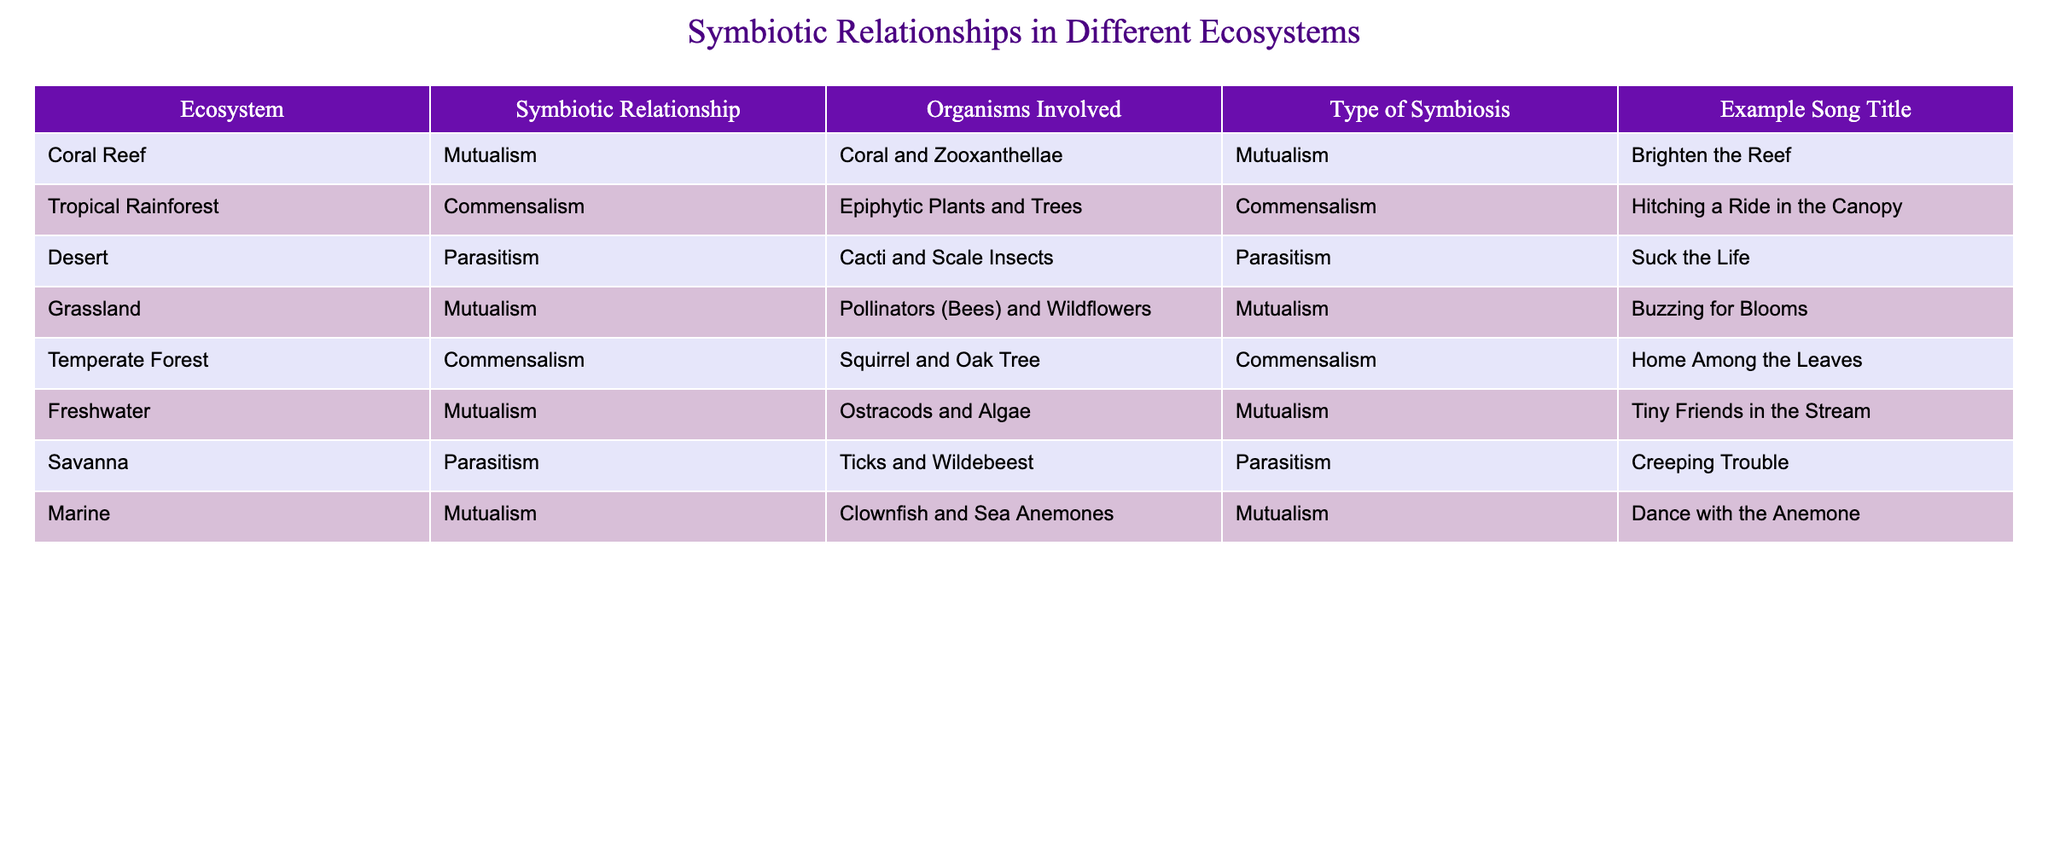What symbiotic relationship do coral and zooxanthellae exhibit? The table indicates that coral and zooxanthellae engage in mutualism, as listed in the corresponding row for the Coral Reef ecosystem.
Answer: Mutualism Which type of symbiosis is represented by the cacti and scale insects? The table clearly shows that the relationship between cacti and scale insects is classified as parasitism, as seen in the Desert ecosystem row.
Answer: Parasitism How many symbiotic relationships are classified as mutualism in the table? By examining the table, I can count three rows that indicate mutualism, specifically Coral and Zooxanthellae, Pollinators and Wildflowers, and Clownfish and Sea Anemones.
Answer: Three Is the relationship between ticks and wildebeest mutualism? The table states that the relationship between ticks and wildebeest is classified as parasitism, so the relationship is not mutualism.
Answer: No Which ecosystem features a commensal relationship involving a squirrel? Looking at the table, I can see that the Temperate Forest ecosystem features a commensal relationship involving a squirrel and an oak tree.
Answer: Temperate Forest If someone were to create a song about ostracods and algae, what title would they use according to the table? The table indicates that the song title for the mutualism between ostracods and algae is "Tiny Friends in the Stream," as provided in the corresponding row.
Answer: Tiny Friends in the Stream What is the average number of organisms involved in mutualistic relationships listed in the table? The mutualistic relationships involve: 2 (Coral and Zooxanthellae), 2 (Pollinators and Wildflowers), and 2 (Clownfish and Sea Anemones), totaling 6 organisms. Therefore, the average is 6 organisms divided by 3 relationships, which equals 2.
Answer: 2 Which two types of symbiosis are represented in the table, and how do they differ? The table includes mutualism and parasitism. Mutualism is a relationship where both organisms benefit, such as coral and zooxanthellae, while parasitism involves one organism benefiting at the expense of the other, as seen in the relationship between ticks and wildebeest.
Answer: Mutualism and Parasitism How does the relationship type of epiphytic plants and trees differ from that of clownfish and sea anemones? The relationship between epiphytic plants and trees is classified as commensalism, meaning one organism benefits while the other is neither helped nor harmed. In contrast, the relationship between clownfish and sea anemones is mutualism, where both organisms benefit from the interaction.
Answer: They differ in that one is commensalism and the other is mutualism 